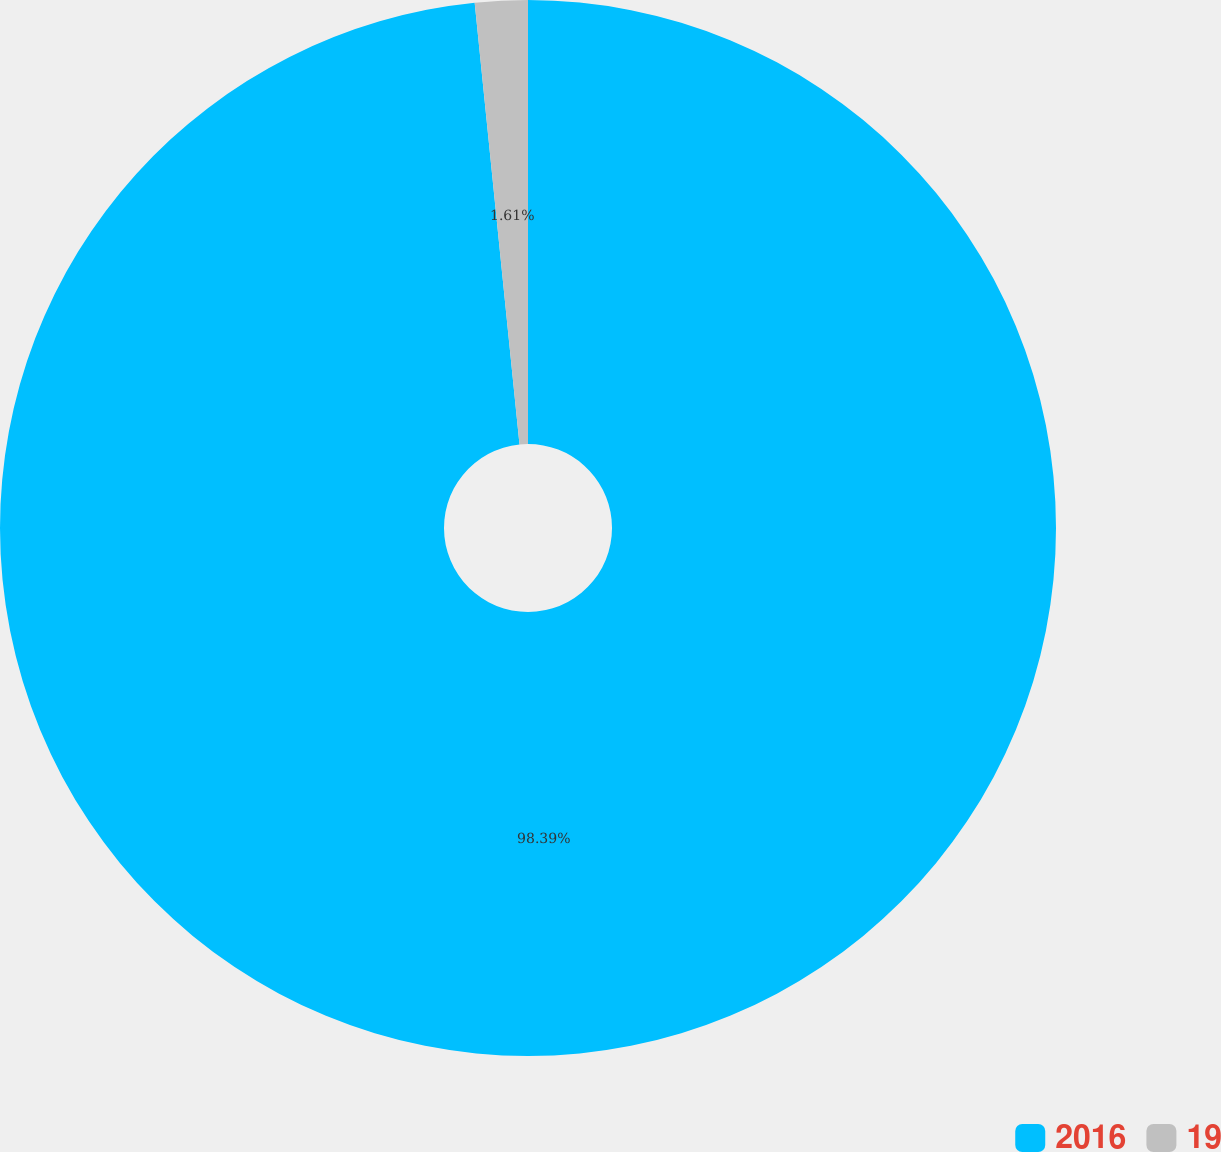Convert chart to OTSL. <chart><loc_0><loc_0><loc_500><loc_500><pie_chart><fcel>2016<fcel>19<nl><fcel>98.39%<fcel>1.61%<nl></chart> 